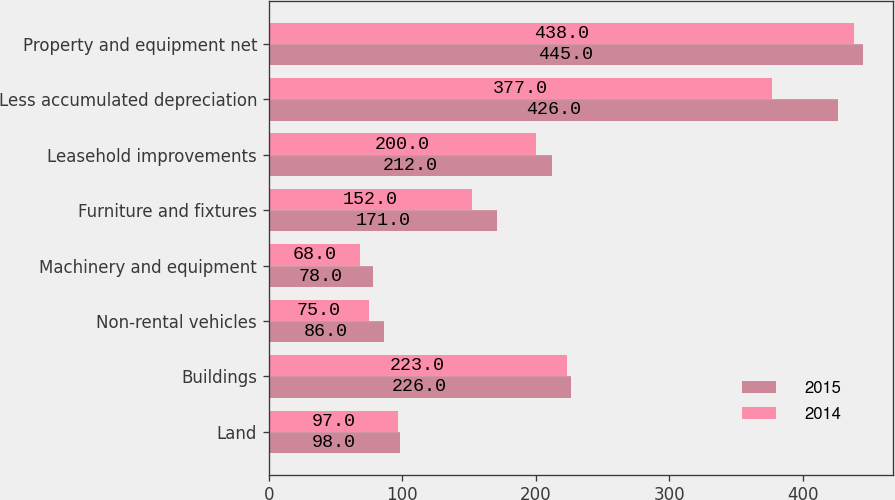Convert chart. <chart><loc_0><loc_0><loc_500><loc_500><stacked_bar_chart><ecel><fcel>Land<fcel>Buildings<fcel>Non-rental vehicles<fcel>Machinery and equipment<fcel>Furniture and fixtures<fcel>Leasehold improvements<fcel>Less accumulated depreciation<fcel>Property and equipment net<nl><fcel>2015<fcel>98<fcel>226<fcel>86<fcel>78<fcel>171<fcel>212<fcel>426<fcel>445<nl><fcel>2014<fcel>97<fcel>223<fcel>75<fcel>68<fcel>152<fcel>200<fcel>377<fcel>438<nl></chart> 